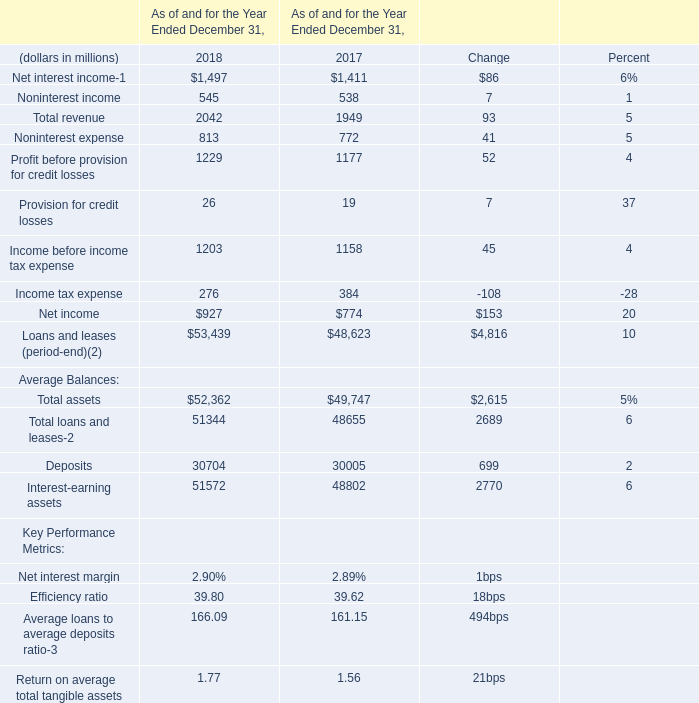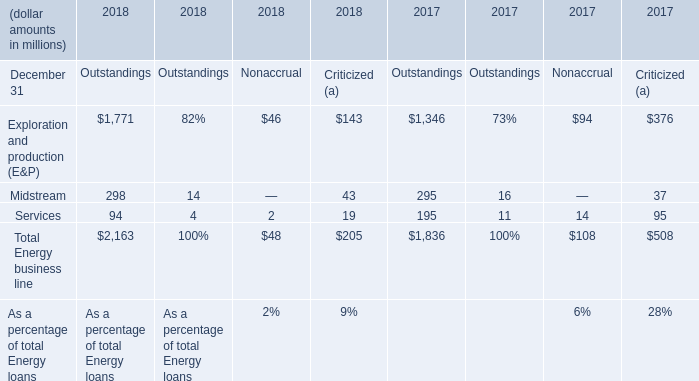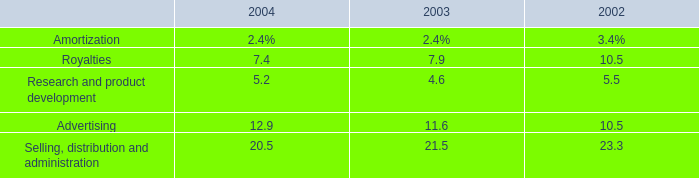What was the total amount of Average Balances in 2018? (in million) 
Computations: (((52362 + 51344) + 30704) + 51572)
Answer: 185982.0. 